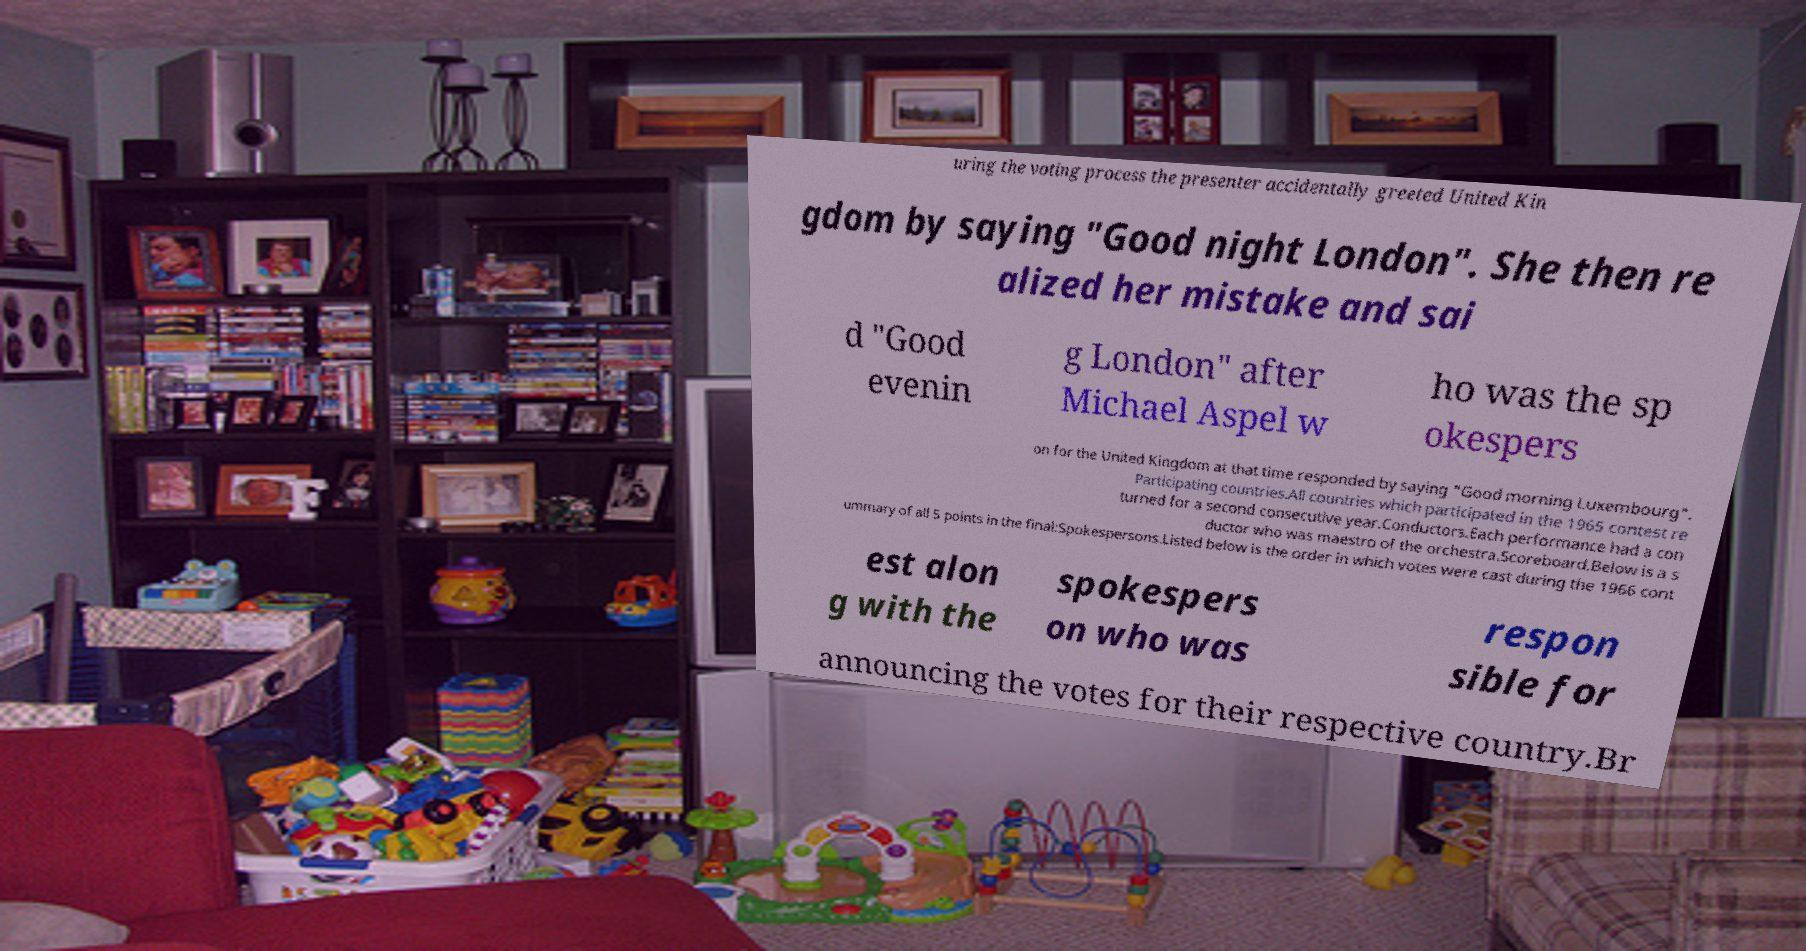For documentation purposes, I need the text within this image transcribed. Could you provide that? uring the voting process the presenter accidentally greeted United Kin gdom by saying "Good night London". She then re alized her mistake and sai d "Good evenin g London" after Michael Aspel w ho was the sp okespers on for the United Kingdom at that time responded by saying "Good morning Luxembourg". Participating countries.All countries which participated in the 1965 contest re turned for a second consecutive year.Conductors.Each performance had a con ductor who was maestro of the orchestra.Scoreboard.Below is a s ummary of all 5 points in the final:Spokespersons.Listed below is the order in which votes were cast during the 1966 cont est alon g with the spokespers on who was respon sible for announcing the votes for their respective country.Br 